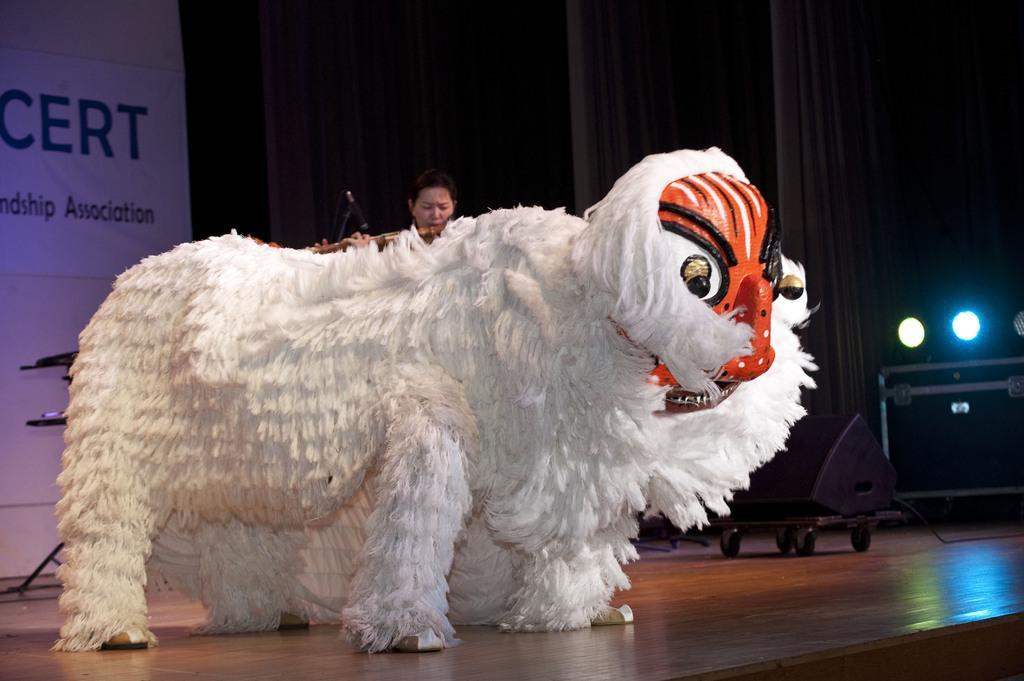Could you give a brief overview of what you see in this image? It's a doll in the shape of a sheep in white color and here a woman is looking at this. On the right side there are plants. 